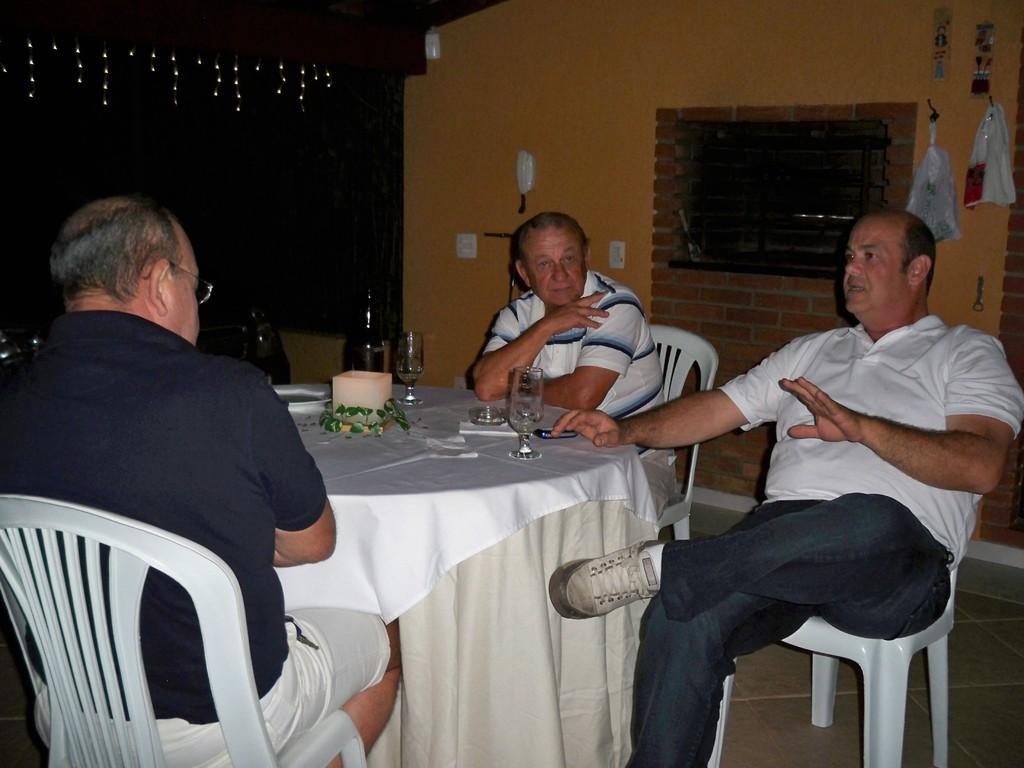How would you summarize this image in a sentence or two? In this image i can see three man sitting there are two glasses,two bottles on a table at the back ground i can see a wall, a window and a carry bag. 